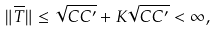<formula> <loc_0><loc_0><loc_500><loc_500>\| \overline { T } \| \leq \sqrt { C C ^ { \prime } } + K \sqrt { C C ^ { \prime } } < \infty ,</formula> 